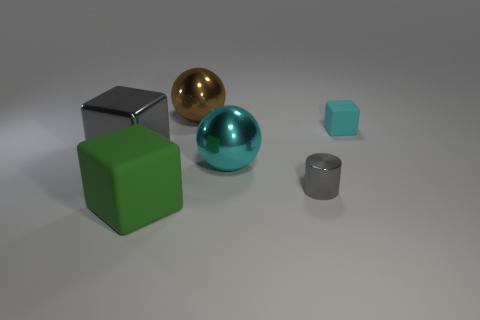Are there any big green things?
Keep it short and to the point. Yes. Are there the same number of metallic balls and green cubes?
Provide a short and direct response. No. What number of tiny cubes have the same color as the small cylinder?
Provide a succinct answer. 0. Are the cyan cube and the big thing that is in front of the cylinder made of the same material?
Provide a succinct answer. Yes. Are there more blocks right of the large brown thing than gray things?
Provide a short and direct response. No. Is there any other thing that has the same size as the cyan shiny sphere?
Keep it short and to the point. Yes. There is a large metallic block; does it have the same color as the rubber cube that is in front of the cyan rubber object?
Make the answer very short. No. Are there the same number of matte things that are behind the tiny cylinder and shiny things that are on the right side of the large gray metal thing?
Keep it short and to the point. No. There is a sphere to the right of the brown shiny thing; what is its material?
Ensure brevity in your answer.  Metal. How many objects are either rubber cubes in front of the cyan matte block or big gray blocks?
Your answer should be compact. 2. 